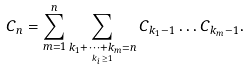Convert formula to latex. <formula><loc_0><loc_0><loc_500><loc_500>C _ { n } = \sum _ { m = 1 } ^ { n } \sum _ { \underset { k _ { i } \geq 1 } { k _ { 1 } + \dots + k _ { m } = n } } C _ { k _ { 1 } - 1 } \dots C _ { k _ { m } - 1 } .</formula> 